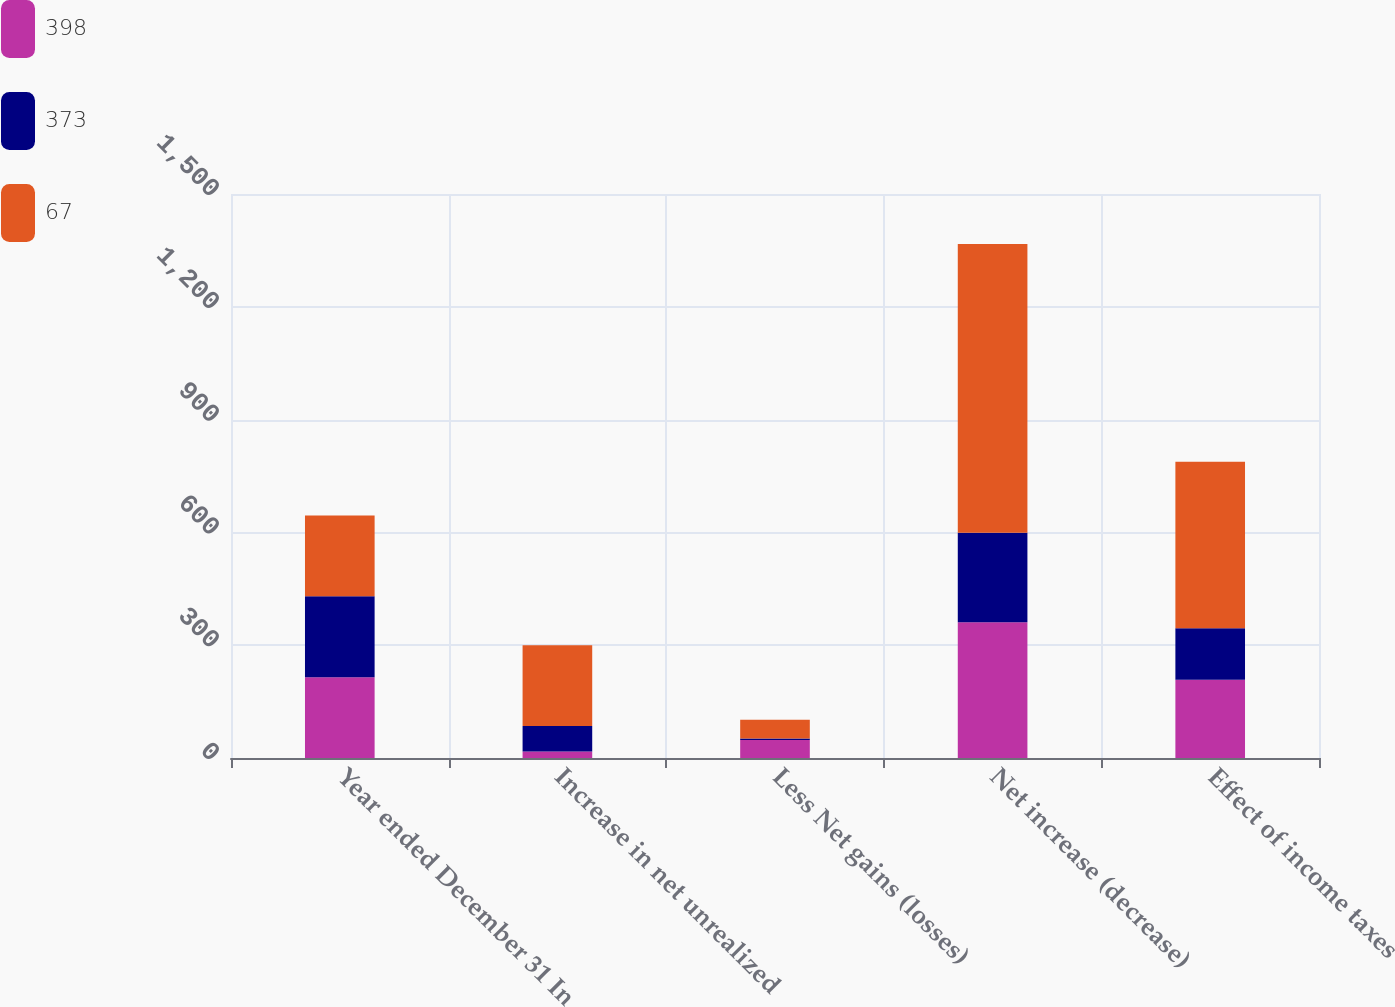Convert chart to OTSL. <chart><loc_0><loc_0><loc_500><loc_500><stacked_bar_chart><ecel><fcel>Year ended December 31 In<fcel>Increase in net unrealized<fcel>Less Net gains (losses)<fcel>Net increase (decrease)<fcel>Effect of income taxes<nl><fcel>398<fcel>215<fcel>17<fcel>48<fcel>361<fcel>208<nl><fcel>373<fcel>215<fcel>68<fcel>4<fcel>238<fcel>137<nl><fcel>67<fcel>215<fcel>215<fcel>50<fcel>768<fcel>443<nl></chart> 